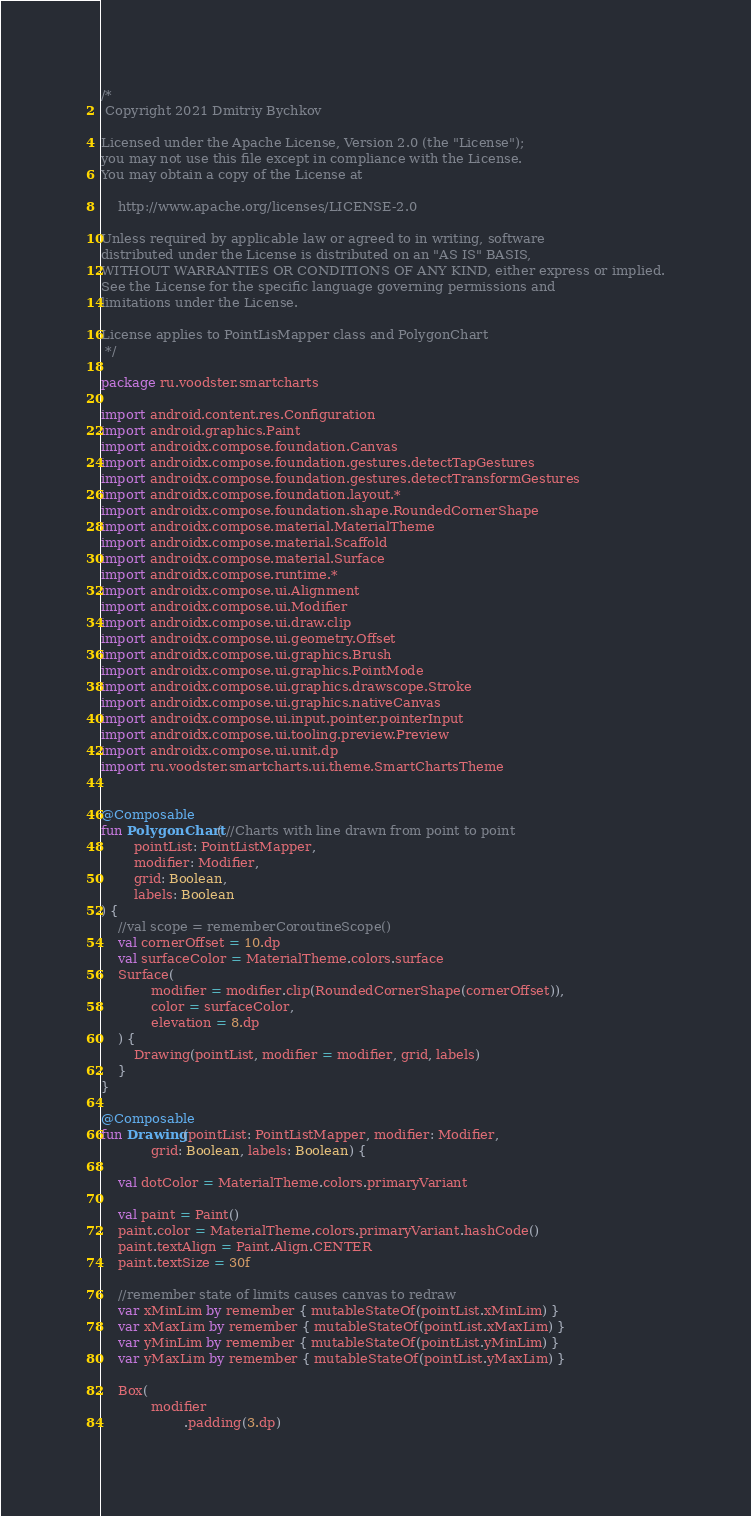<code> <loc_0><loc_0><loc_500><loc_500><_Kotlin_>/*
 Copyright 2021 Dmitriy Bychkov

Licensed under the Apache License, Version 2.0 (the "License");
you may not use this file except in compliance with the License.
You may obtain a copy of the License at

    http://www.apache.org/licenses/LICENSE-2.0

Unless required by applicable law or agreed to in writing, software
distributed under the License is distributed on an "AS IS" BASIS,
WITHOUT WARRANTIES OR CONDITIONS OF ANY KIND, either express or implied.
See the License for the specific language governing permissions and
limitations under the License.

License applies to PointLisMapper class and PolygonChart
 */

package ru.voodster.smartcharts

import android.content.res.Configuration
import android.graphics.Paint
import androidx.compose.foundation.Canvas
import androidx.compose.foundation.gestures.detectTapGestures
import androidx.compose.foundation.gestures.detectTransformGestures
import androidx.compose.foundation.layout.*
import androidx.compose.foundation.shape.RoundedCornerShape
import androidx.compose.material.MaterialTheme
import androidx.compose.material.Scaffold
import androidx.compose.material.Surface
import androidx.compose.runtime.*
import androidx.compose.ui.Alignment
import androidx.compose.ui.Modifier
import androidx.compose.ui.draw.clip
import androidx.compose.ui.geometry.Offset
import androidx.compose.ui.graphics.Brush
import androidx.compose.ui.graphics.PointMode
import androidx.compose.ui.graphics.drawscope.Stroke
import androidx.compose.ui.graphics.nativeCanvas
import androidx.compose.ui.input.pointer.pointerInput
import androidx.compose.ui.tooling.preview.Preview
import androidx.compose.ui.unit.dp
import ru.voodster.smartcharts.ui.theme.SmartChartsTheme


@Composable
fun PolygonChart( //Charts with line drawn from point to point
        pointList: PointListMapper,
        modifier: Modifier,
        grid: Boolean,
        labels: Boolean
) {
    //val scope = rememberCoroutineScope()
    val cornerOffset = 10.dp
    val surfaceColor = MaterialTheme.colors.surface
    Surface(
            modifier = modifier.clip(RoundedCornerShape(cornerOffset)),
            color = surfaceColor,
            elevation = 8.dp
    ) {
        Drawing(pointList, modifier = modifier, grid, labels)
    }
}

@Composable
fun Drawing(pointList: PointListMapper, modifier: Modifier,
            grid: Boolean, labels: Boolean) {

    val dotColor = MaterialTheme.colors.primaryVariant

    val paint = Paint()
    paint.color = MaterialTheme.colors.primaryVariant.hashCode()
    paint.textAlign = Paint.Align.CENTER
    paint.textSize = 30f

    //remember state of limits causes canvas to redraw
    var xMinLim by remember { mutableStateOf(pointList.xMinLim) }
    var xMaxLim by remember { mutableStateOf(pointList.xMaxLim) }
    var yMinLim by remember { mutableStateOf(pointList.yMinLim) }
    var yMaxLim by remember { mutableStateOf(pointList.yMaxLim) }

    Box(
            modifier
                    .padding(3.dp)</code> 